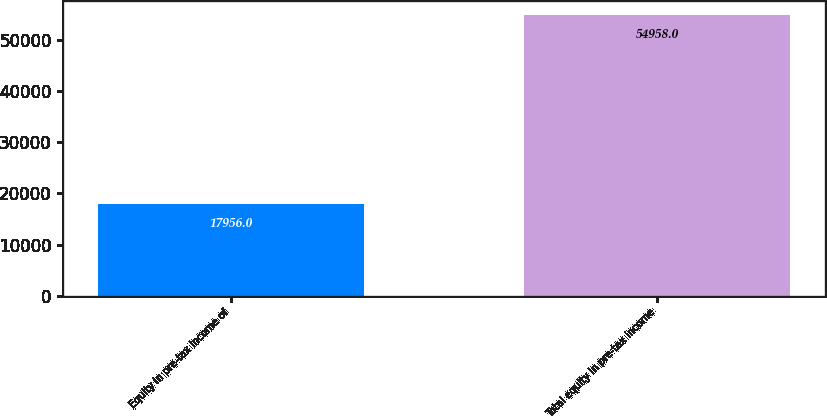<chart> <loc_0><loc_0><loc_500><loc_500><bar_chart><fcel>Equity in pre-tax income of<fcel>Total equity in pre-tax income<nl><fcel>17956<fcel>54958<nl></chart> 